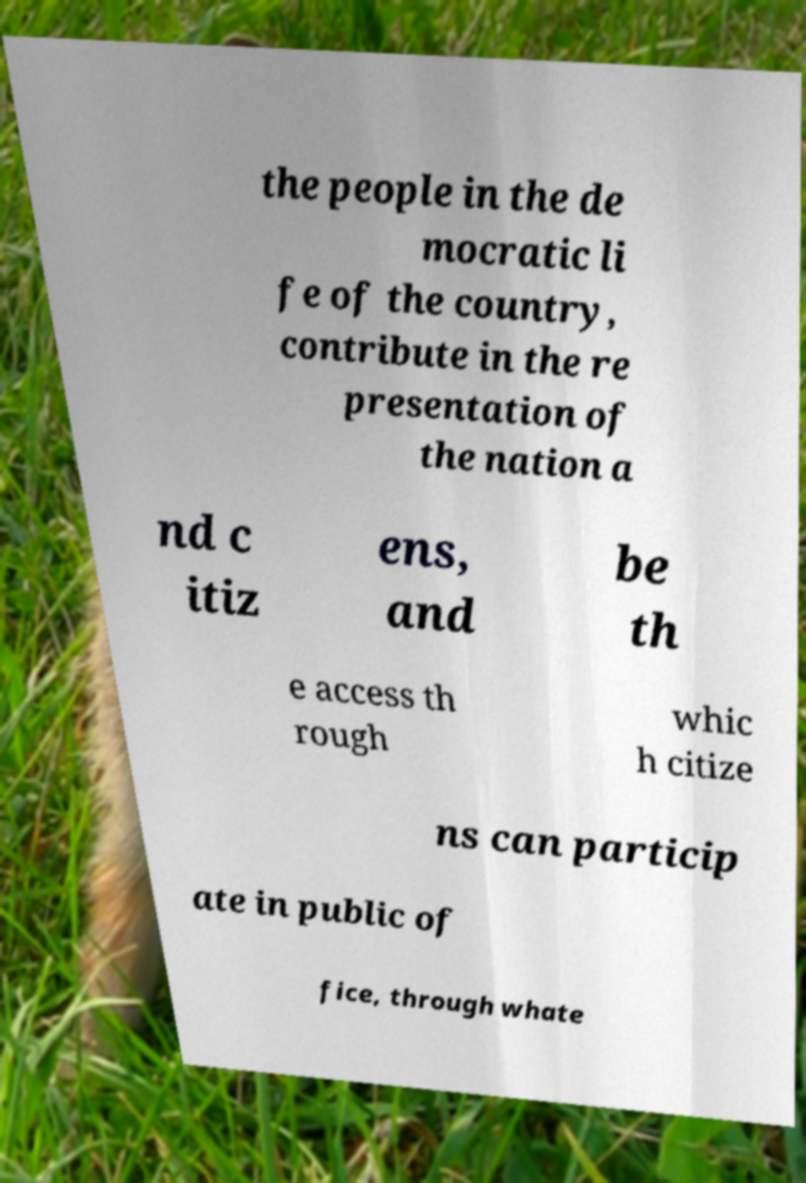There's text embedded in this image that I need extracted. Can you transcribe it verbatim? the people in the de mocratic li fe of the country, contribute in the re presentation of the nation a nd c itiz ens, and be th e access th rough whic h citize ns can particip ate in public of fice, through whate 